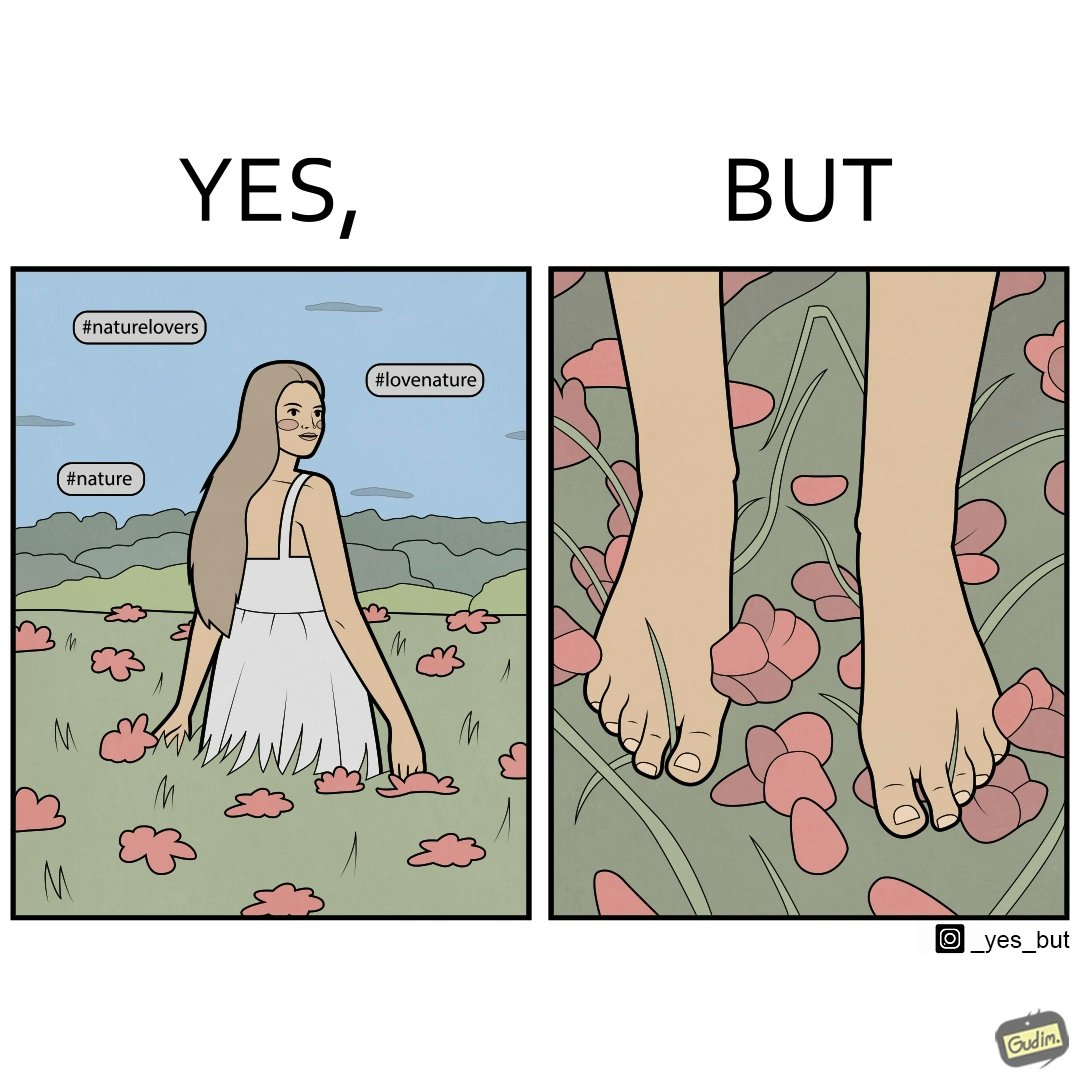Why is this image considered satirical? The image is ironical, as the social ,edia post shows the appreciation of nature, while an image of the feet on the ground stepping on the flower petals shows an unintentional disrespect of nature. 